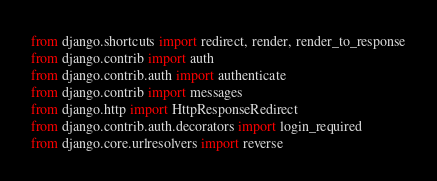<code> <loc_0><loc_0><loc_500><loc_500><_Python_>from django.shortcuts import redirect, render, render_to_response
from django.contrib import auth
from django.contrib.auth import authenticate
from django.contrib import messages
from django.http import HttpResponseRedirect
from django.contrib.auth.decorators import login_required
from django.core.urlresolvers import reverse</code> 